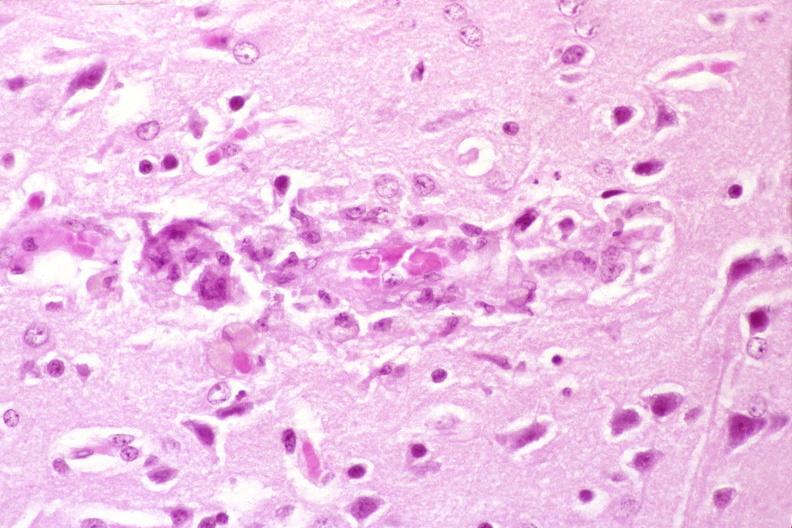where is this?
Answer the question using a single word or phrase. Nervous 